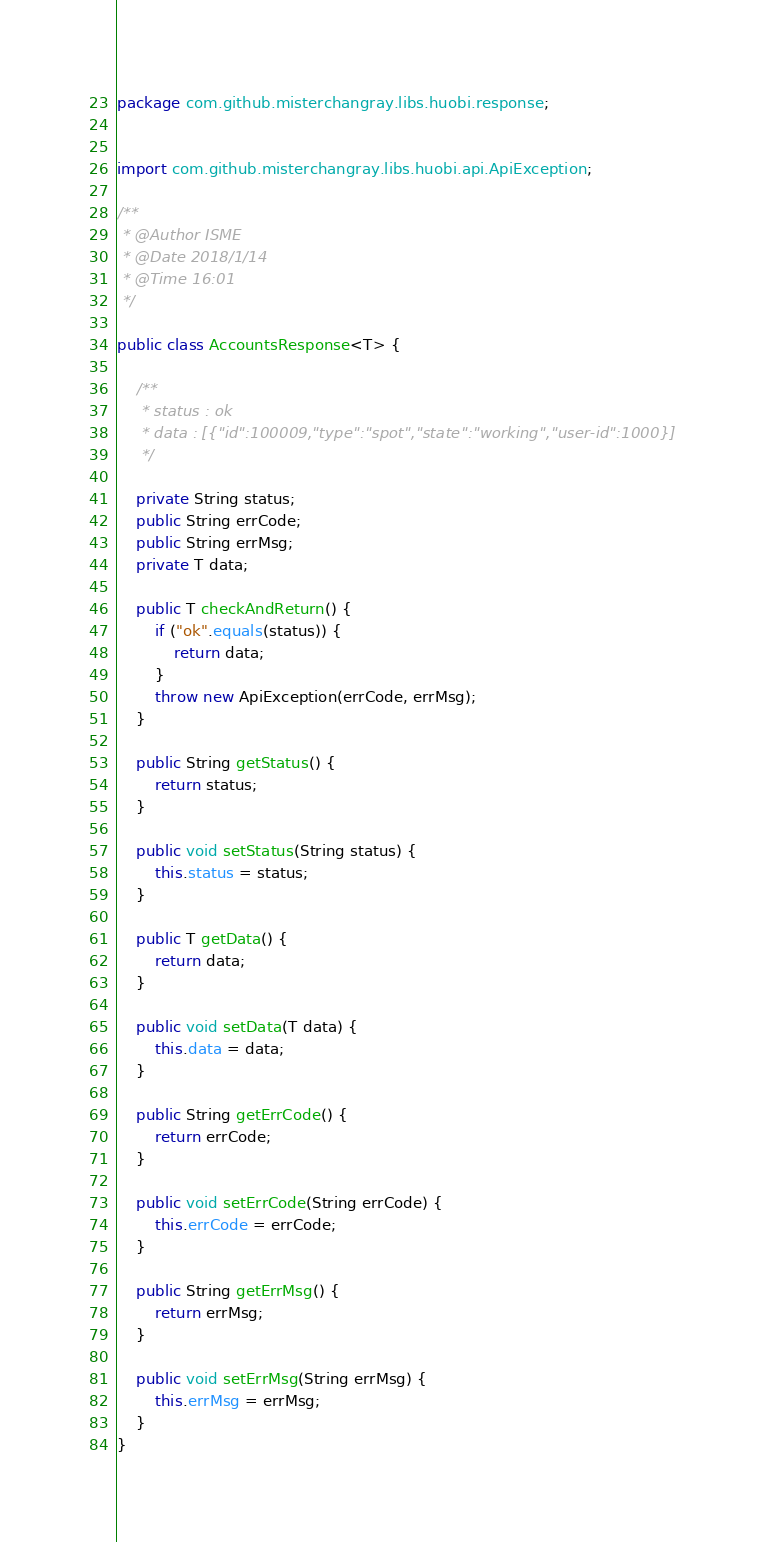<code> <loc_0><loc_0><loc_500><loc_500><_Java_>package com.github.misterchangray.libs.huobi.response;


import com.github.misterchangray.libs.huobi.api.ApiException;

/**
 * @Author ISME
 * @Date 2018/1/14
 * @Time 16:01
 */

public class AccountsResponse<T> {

    /**
     * status : ok
     * data : [{"id":100009,"type":"spot","state":"working","user-id":1000}]
     */

    private String status;
    public String errCode;
    public String errMsg;
    private T data;

    public T checkAndReturn() {
        if ("ok".equals(status)) {
            return data;
        }
        throw new ApiException(errCode, errMsg);
    }

    public String getStatus() {
        return status;
    }

    public void setStatus(String status) {
        this.status = status;
    }

    public T getData() {
        return data;
    }

    public void setData(T data) {
        this.data = data;
    }

    public String getErrCode() {
        return errCode;
    }

    public void setErrCode(String errCode) {
        this.errCode = errCode;
    }

    public String getErrMsg() {
        return errMsg;
    }

    public void setErrMsg(String errMsg) {
        this.errMsg = errMsg;
    }
}
</code> 